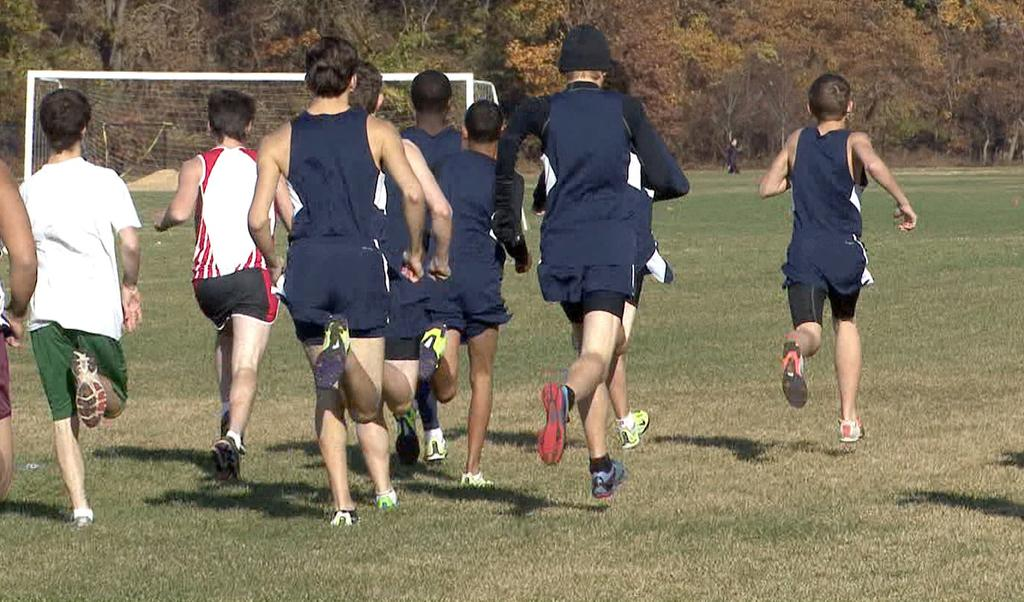What are the people in the image doing? The people in the image are running. What surface are the people running on? The people are running on the grass. What can be seen in the background of the image? There is a net and trees visible in the background of the image. What type of sign can be seen near the seashore in the image? There is no sign or seashore present in the image; it features people running on grass with a net and trees in the background. 